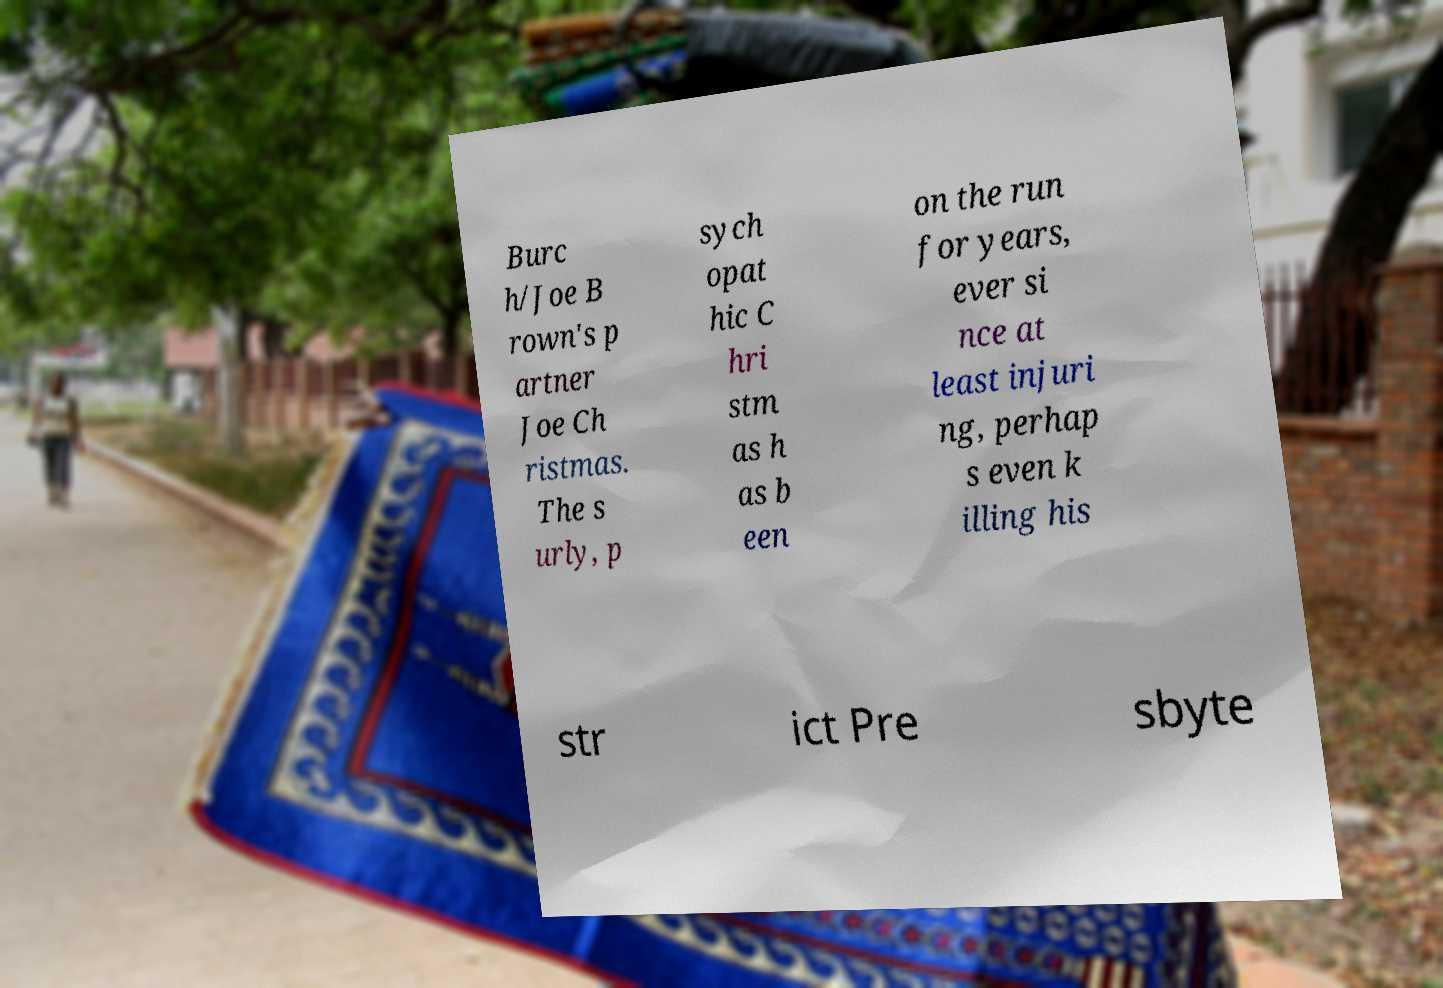For documentation purposes, I need the text within this image transcribed. Could you provide that? Burc h/Joe B rown's p artner Joe Ch ristmas. The s urly, p sych opat hic C hri stm as h as b een on the run for years, ever si nce at least injuri ng, perhap s even k illing his str ict Pre sbyte 